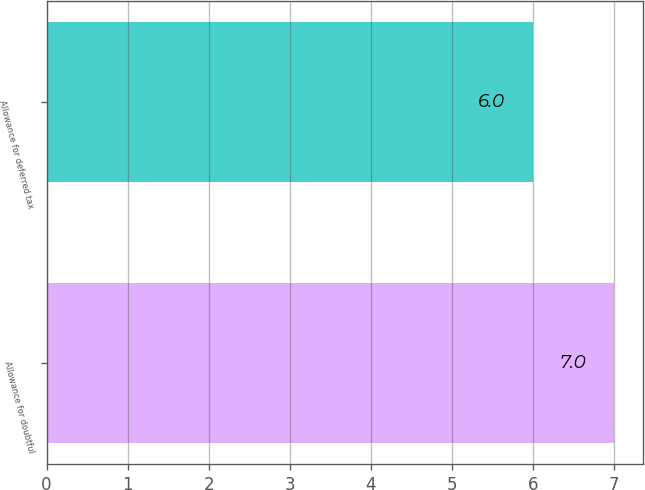Convert chart. <chart><loc_0><loc_0><loc_500><loc_500><bar_chart><fcel>Allowance for doubtful<fcel>Allowance for deferred tax<nl><fcel>7<fcel>6<nl></chart> 